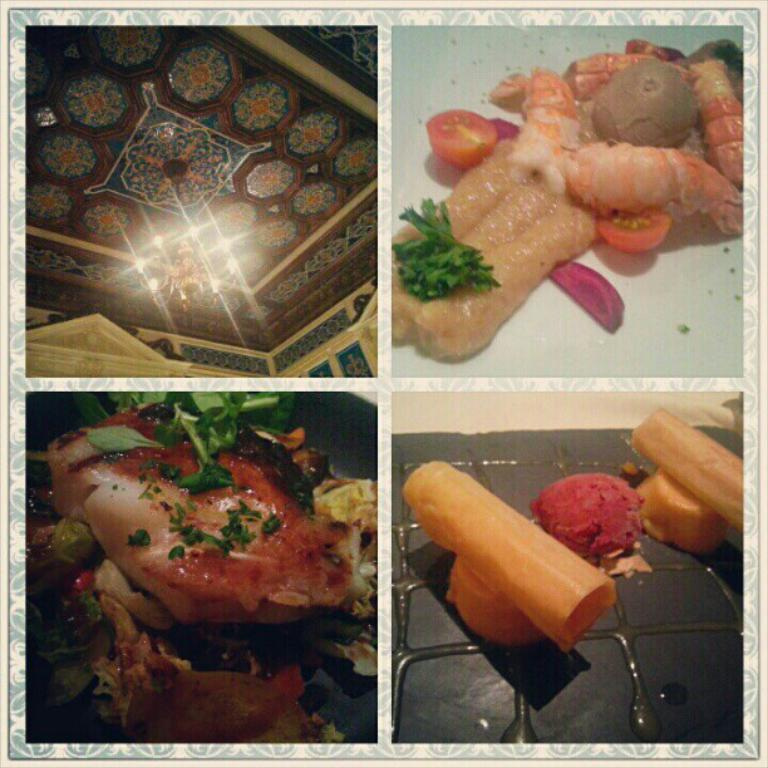What type of artwork is depicted in the image? The image is a collage. What can be found within the collage? There are food items in the collage. What type of property is being sold in the image? There is no property being sold in the image; it is a collage of food items. What impulse might someone have when looking at the food items in the image? The image does not convey any impulses or emotions; it is simply a collage of food items. 